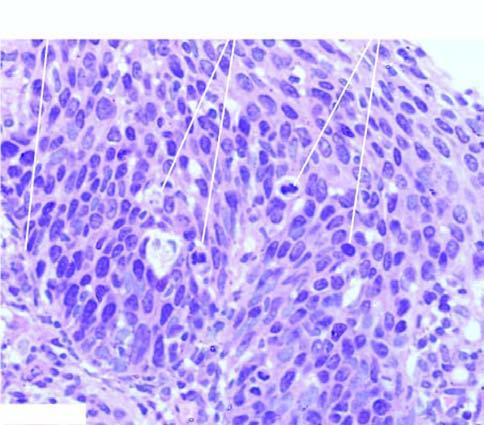s these layers rest intact?
Answer the question using a single word or phrase. Yes 